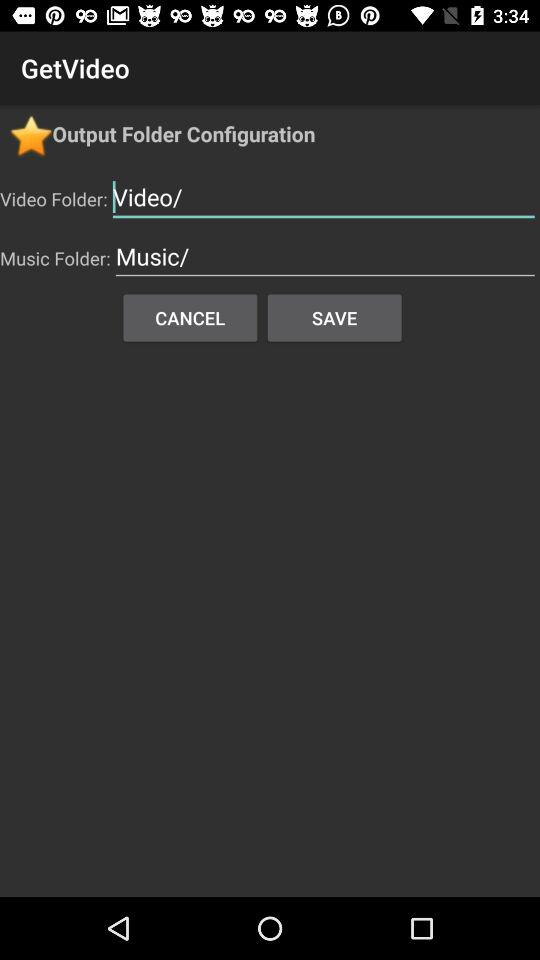What is the application name? The application name is "GetVideo". 